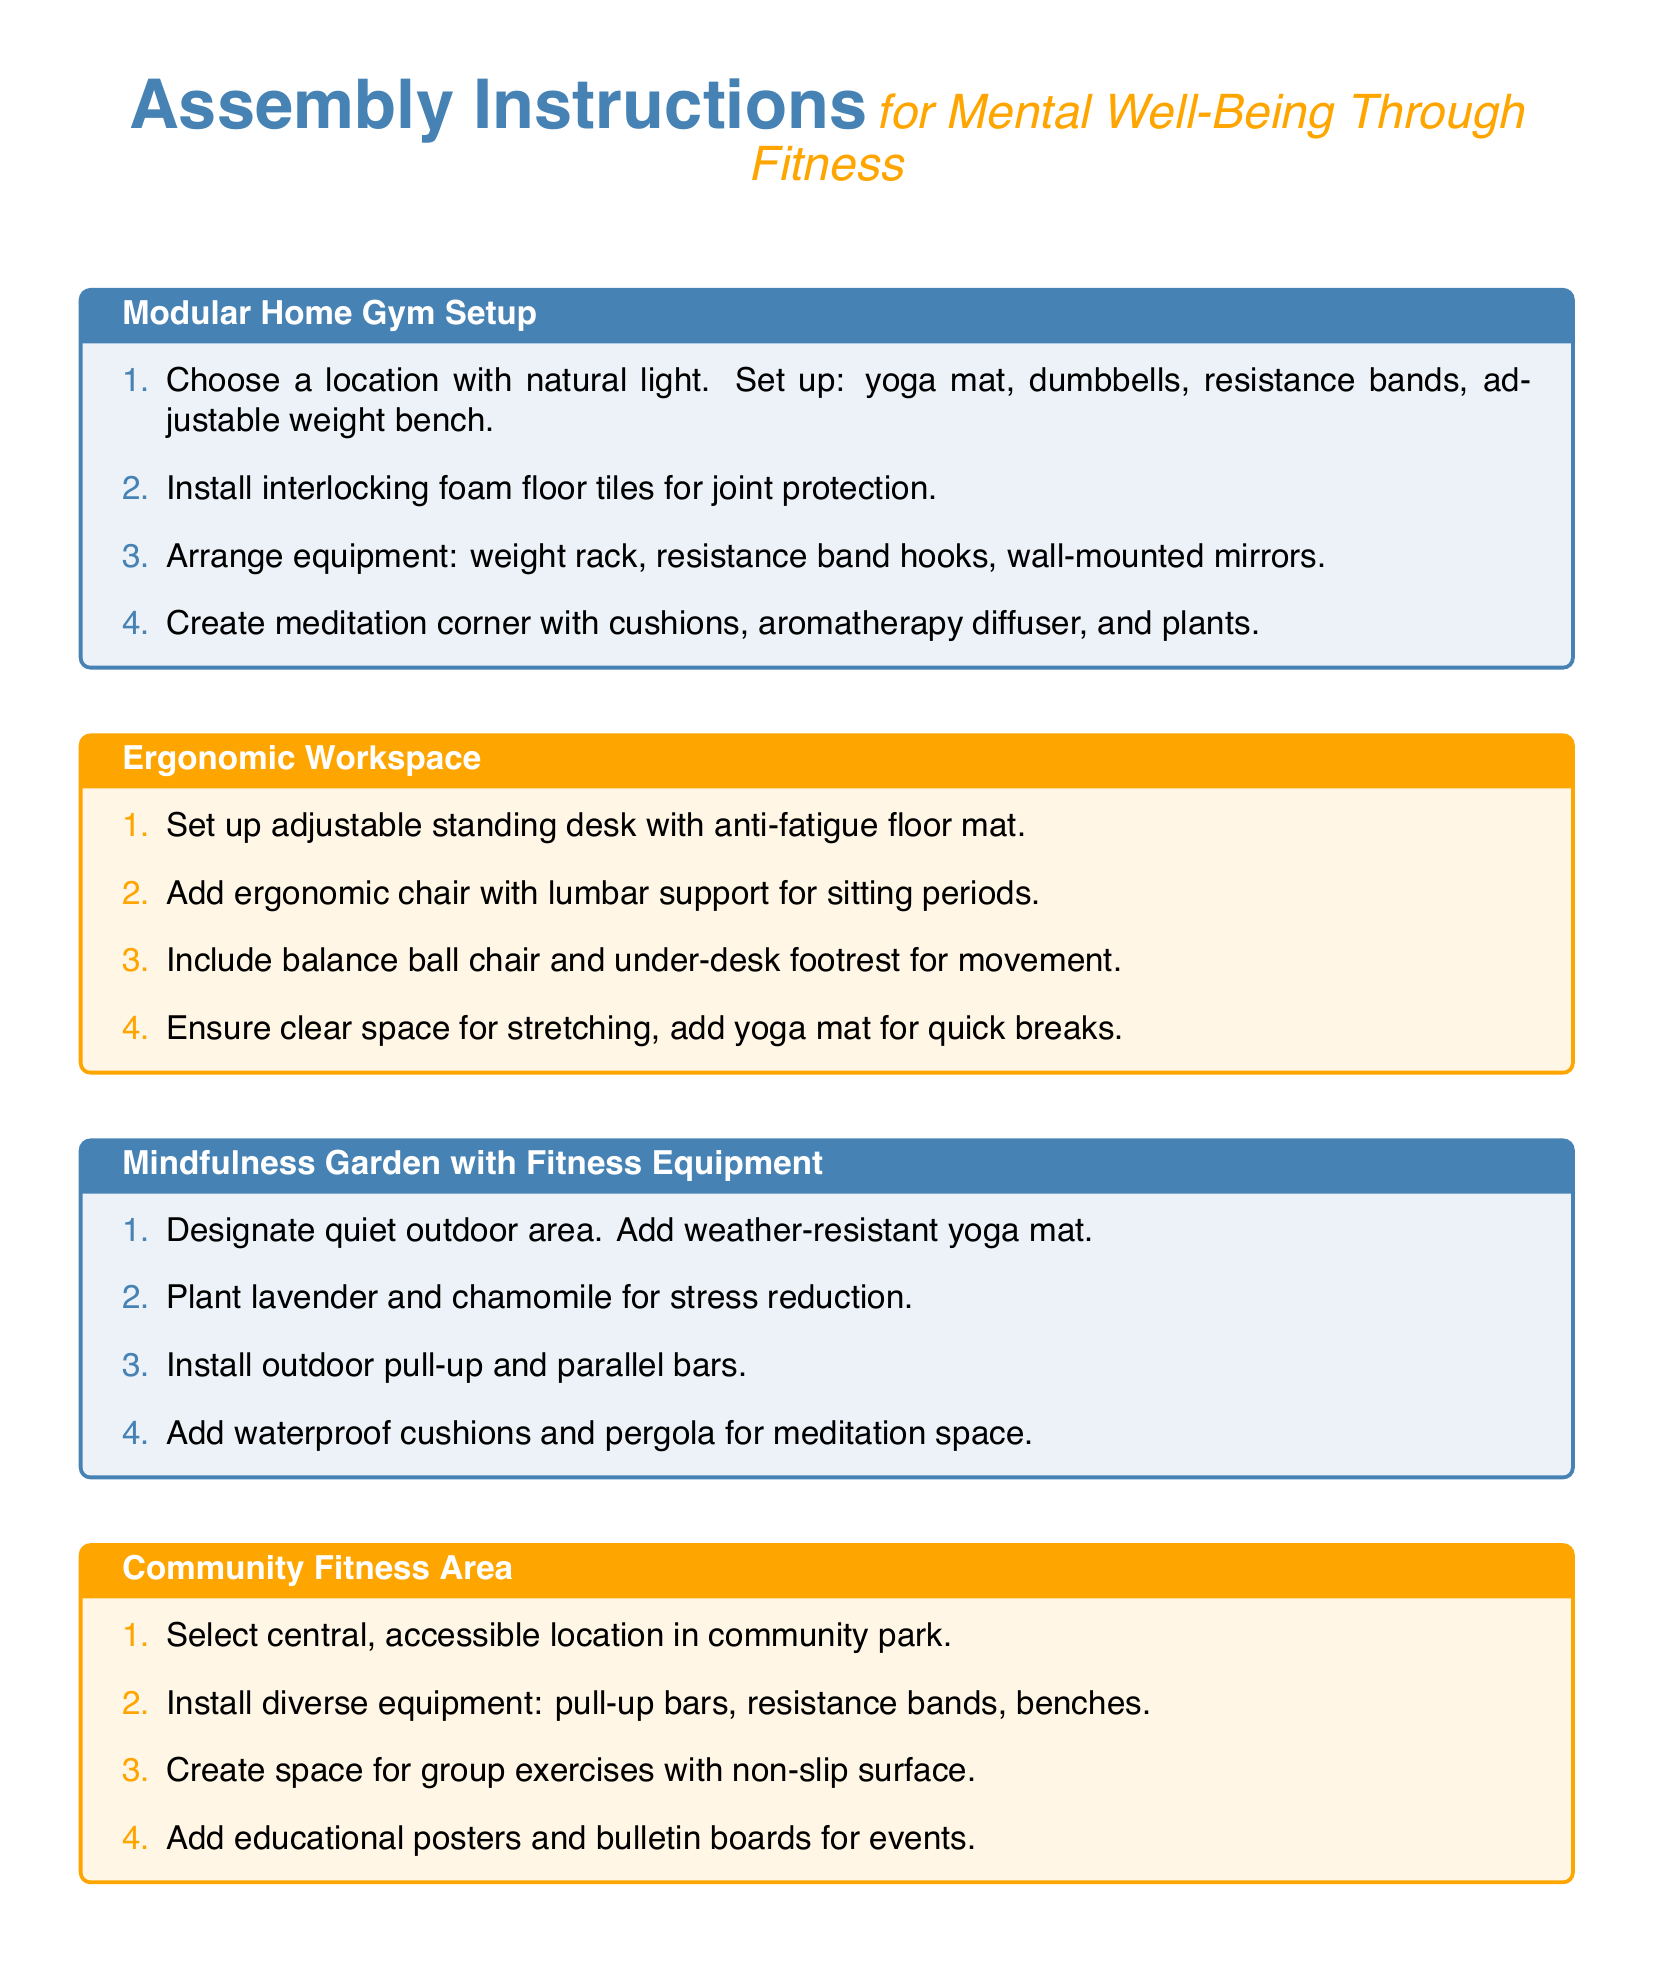What is the color theme for the modular home gym setup? The color theme is represented by the title in the document, which uses the color mindful blue.
Answer: mindful blue How many steps are there in the ergonomic workspace section? The document lists four specific steps for setting up the ergonomic workspace.
Answer: 4 What type of chair is suggested for an ergonomic workspace? The instructions specify adding an ergonomic chair that provides lumbar support for sitting periods.
Answer: ergonomic chair What type of plants are recommended for the mindfulness garden? The documents suggests planting lavender and chamomile for stress reduction in the mindfulness garden.
Answer: lavender and chamomile What equipment is included in the community fitness area setup? The document mentions the installation of pull-up bars, resistance bands, and benches for the community fitness area.
Answer: pull-up bars, resistance bands, benches How can the wearable fitness technology be connected to mental health apps? The synchronization process involves downloading sync apps and connecting via Bluetooth.
Answer: Bluetooth How many pieces of equipment are suggested for the modular home gym setup? The modular home gym setup includes four specific pieces of equipment listed in the instructions.
Answer: 4 What is the suggested material for the flooring in the modular home gym? The document advises installing interlocking foam floor tiles for joint protection in the gym setup.
Answer: foam floor tiles What feature is important for the space designated for group exercises in the community fitness area? The instructions emphasize the importance of having a non-slip surface for group exercises.
Answer: non-slip surface 